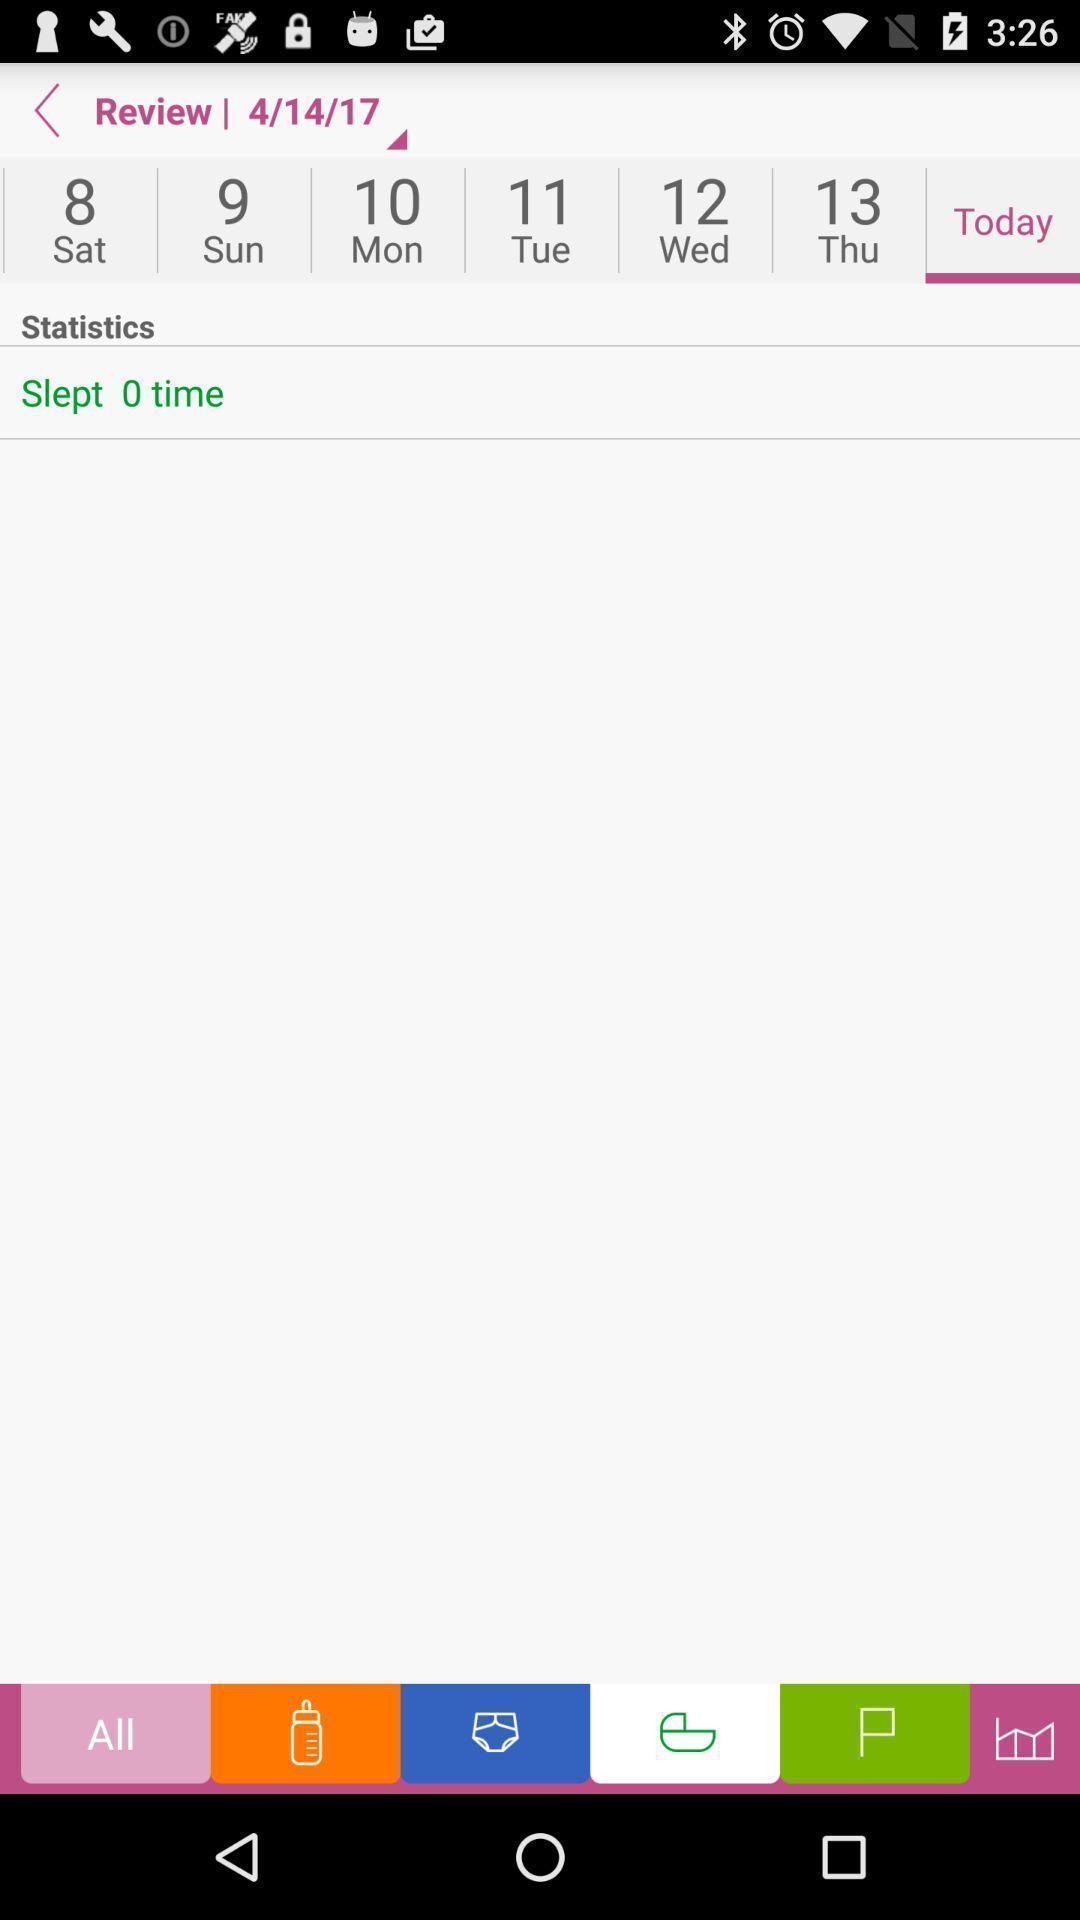Describe the visual elements of this screenshot. Screen shows multiple options. 